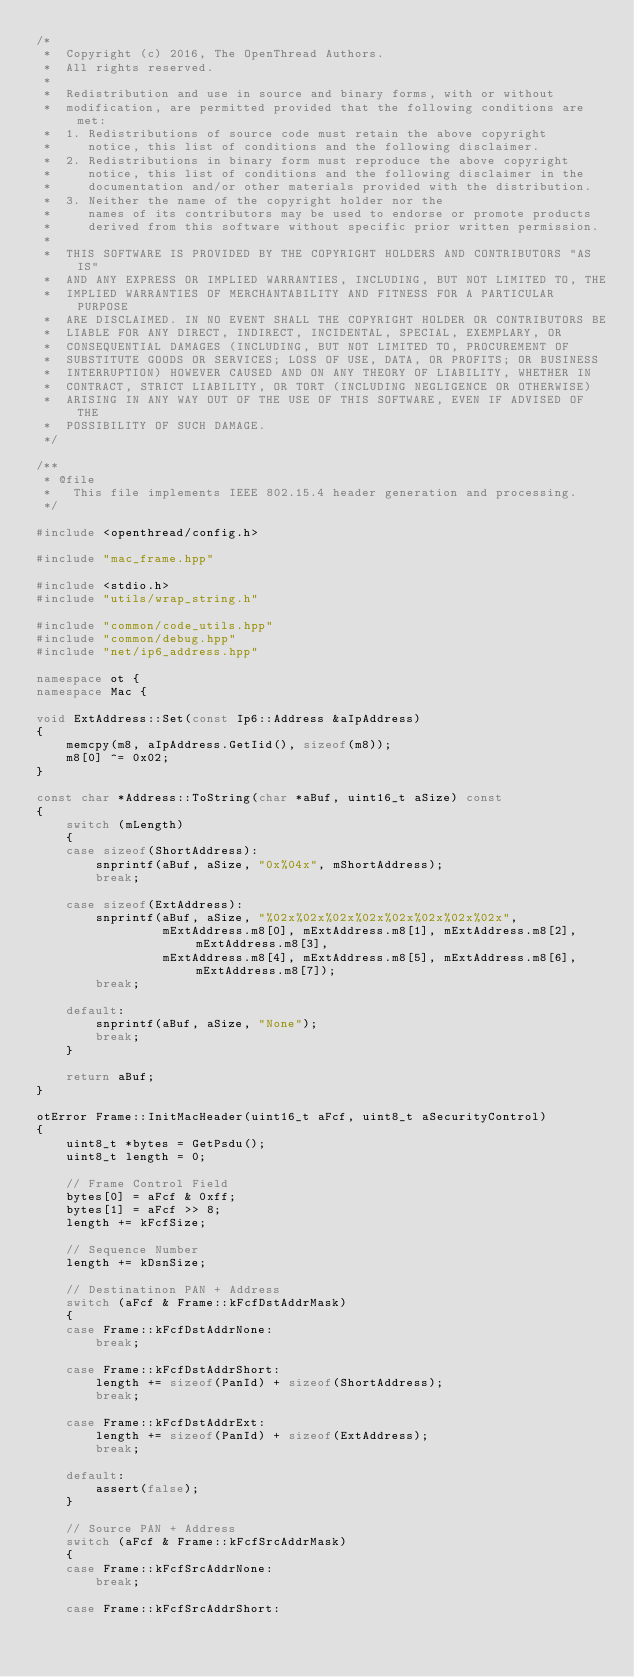Convert code to text. <code><loc_0><loc_0><loc_500><loc_500><_C++_>/*
 *  Copyright (c) 2016, The OpenThread Authors.
 *  All rights reserved.
 *
 *  Redistribution and use in source and binary forms, with or without
 *  modification, are permitted provided that the following conditions are met:
 *  1. Redistributions of source code must retain the above copyright
 *     notice, this list of conditions and the following disclaimer.
 *  2. Redistributions in binary form must reproduce the above copyright
 *     notice, this list of conditions and the following disclaimer in the
 *     documentation and/or other materials provided with the distribution.
 *  3. Neither the name of the copyright holder nor the
 *     names of its contributors may be used to endorse or promote products
 *     derived from this software without specific prior written permission.
 *
 *  THIS SOFTWARE IS PROVIDED BY THE COPYRIGHT HOLDERS AND CONTRIBUTORS "AS IS"
 *  AND ANY EXPRESS OR IMPLIED WARRANTIES, INCLUDING, BUT NOT LIMITED TO, THE
 *  IMPLIED WARRANTIES OF MERCHANTABILITY AND FITNESS FOR A PARTICULAR PURPOSE
 *  ARE DISCLAIMED. IN NO EVENT SHALL THE COPYRIGHT HOLDER OR CONTRIBUTORS BE
 *  LIABLE FOR ANY DIRECT, INDIRECT, INCIDENTAL, SPECIAL, EXEMPLARY, OR
 *  CONSEQUENTIAL DAMAGES (INCLUDING, BUT NOT LIMITED TO, PROCUREMENT OF
 *  SUBSTITUTE GOODS OR SERVICES; LOSS OF USE, DATA, OR PROFITS; OR BUSINESS
 *  INTERRUPTION) HOWEVER CAUSED AND ON ANY THEORY OF LIABILITY, WHETHER IN
 *  CONTRACT, STRICT LIABILITY, OR TORT (INCLUDING NEGLIGENCE OR OTHERWISE)
 *  ARISING IN ANY WAY OUT OF THE USE OF THIS SOFTWARE, EVEN IF ADVISED OF THE
 *  POSSIBILITY OF SUCH DAMAGE.
 */

/**
 * @file
 *   This file implements IEEE 802.15.4 header generation and processing.
 */

#include <openthread/config.h>

#include "mac_frame.hpp"

#include <stdio.h>
#include "utils/wrap_string.h"

#include "common/code_utils.hpp"
#include "common/debug.hpp"
#include "net/ip6_address.hpp"

namespace ot {
namespace Mac {

void ExtAddress::Set(const Ip6::Address &aIpAddress)
{
    memcpy(m8, aIpAddress.GetIid(), sizeof(m8));
    m8[0] ^= 0x02;
}

const char *Address::ToString(char *aBuf, uint16_t aSize) const
{
    switch (mLength)
    {
    case sizeof(ShortAddress):
        snprintf(aBuf, aSize, "0x%04x", mShortAddress);
        break;

    case sizeof(ExtAddress):
        snprintf(aBuf, aSize, "%02x%02x%02x%02x%02x%02x%02x%02x",
                 mExtAddress.m8[0], mExtAddress.m8[1], mExtAddress.m8[2], mExtAddress.m8[3],
                 mExtAddress.m8[4], mExtAddress.m8[5], mExtAddress.m8[6], mExtAddress.m8[7]);
        break;

    default:
        snprintf(aBuf, aSize, "None");
        break;
    }

    return aBuf;
}

otError Frame::InitMacHeader(uint16_t aFcf, uint8_t aSecurityControl)
{
    uint8_t *bytes = GetPsdu();
    uint8_t length = 0;

    // Frame Control Field
    bytes[0] = aFcf & 0xff;
    bytes[1] = aFcf >> 8;
    length += kFcfSize;

    // Sequence Number
    length += kDsnSize;

    // Destinatinon PAN + Address
    switch (aFcf & Frame::kFcfDstAddrMask)
    {
    case Frame::kFcfDstAddrNone:
        break;

    case Frame::kFcfDstAddrShort:
        length += sizeof(PanId) + sizeof(ShortAddress);
        break;

    case Frame::kFcfDstAddrExt:
        length += sizeof(PanId) + sizeof(ExtAddress);
        break;

    default:
        assert(false);
    }

    // Source PAN + Address
    switch (aFcf & Frame::kFcfSrcAddrMask)
    {
    case Frame::kFcfSrcAddrNone:
        break;

    case Frame::kFcfSrcAddrShort:</code> 